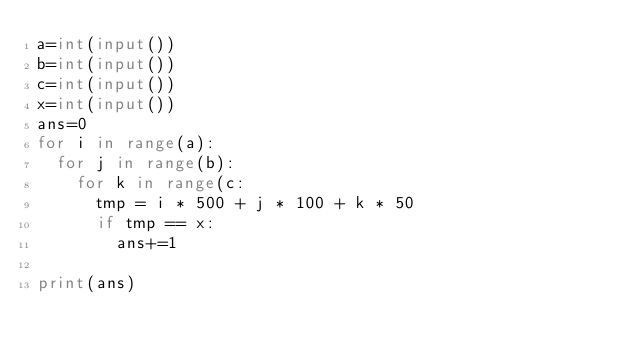Convert code to text. <code><loc_0><loc_0><loc_500><loc_500><_Python_>a=int(input())
b=int(input())
c=int(input())
x=int(input())
ans=0
for i in range(a):
  for j in range(b):
    for k in range(c:
      tmp = i * 500 + j * 100 + k * 50
      if tmp == x:
        ans+=1

print(ans)</code> 